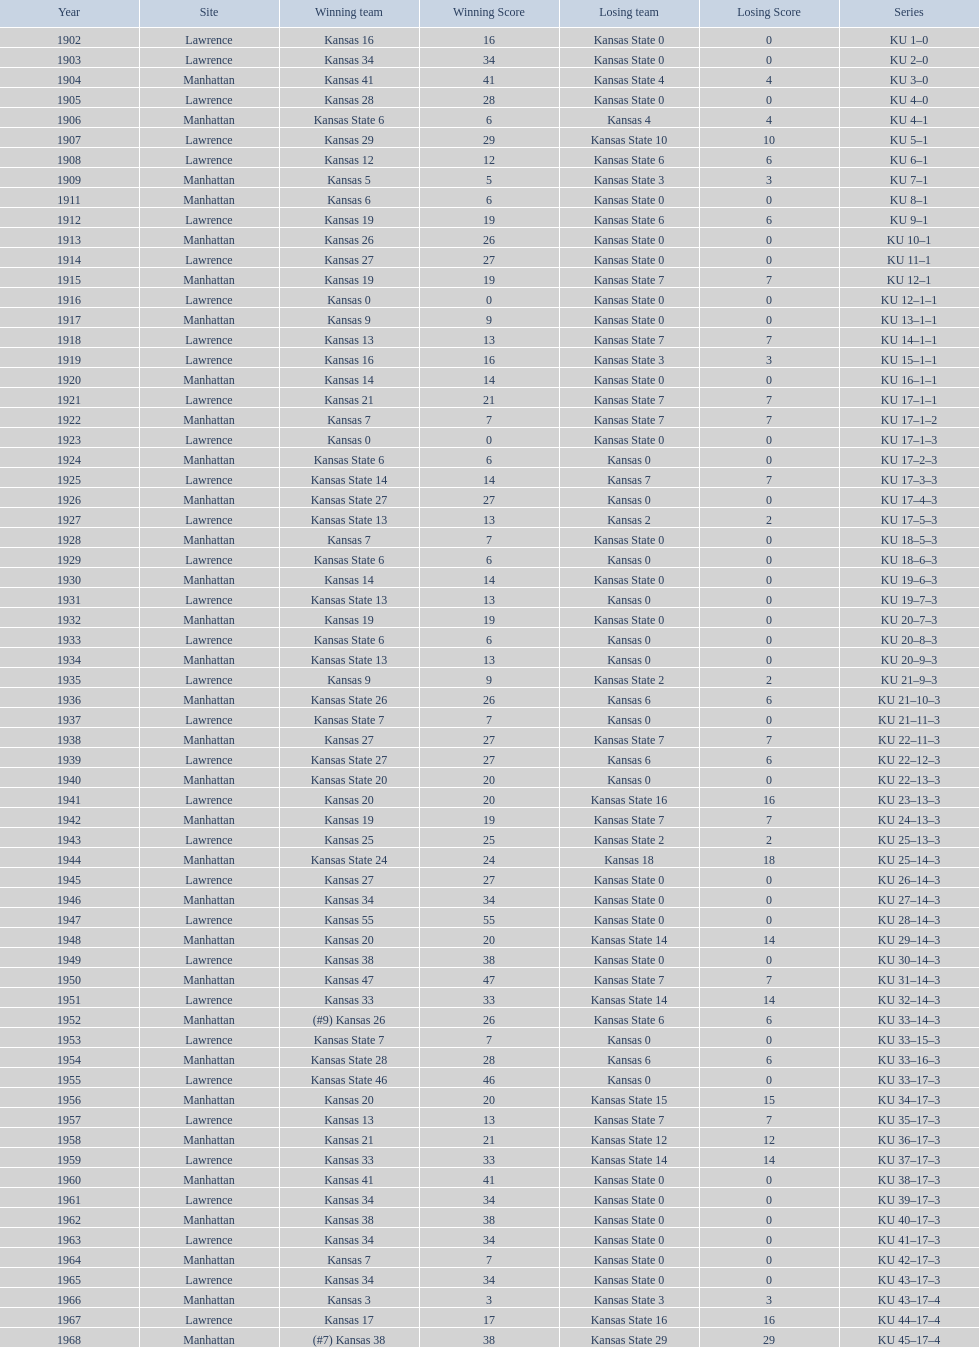I'm looking to parse the entire table for insights. Could you assist me with that? {'header': ['Year', 'Site', 'Winning team', 'Winning Score', 'Losing team', 'Losing Score', 'Series'], 'rows': [['1902', 'Lawrence', 'Kansas 16', '16', 'Kansas State 0', '0', 'KU 1–0'], ['1903', 'Lawrence', 'Kansas 34', '34', 'Kansas State 0', '0', 'KU 2–0'], ['1904', 'Manhattan', 'Kansas 41', '41', 'Kansas State 4', '4', 'KU 3–0'], ['1905', 'Lawrence', 'Kansas 28', '28', 'Kansas State 0', '0', 'KU 4–0'], ['1906', 'Manhattan', 'Kansas State 6', '6', 'Kansas 4', '4', 'KU 4–1'], ['1907', 'Lawrence', 'Kansas 29', '29', 'Kansas State 10', '10', 'KU 5–1'], ['1908', 'Lawrence', 'Kansas 12', '12', 'Kansas State 6', '6', 'KU 6–1'], ['1909', 'Manhattan', 'Kansas 5', '5', 'Kansas State 3', '3', 'KU 7–1'], ['1911', 'Manhattan', 'Kansas 6', '6', 'Kansas State 0', '0', 'KU 8–1'], ['1912', 'Lawrence', 'Kansas 19', '19', 'Kansas State 6', '6', 'KU 9–1'], ['1913', 'Manhattan', 'Kansas 26', '26', 'Kansas State 0', '0', 'KU 10–1'], ['1914', 'Lawrence', 'Kansas 27', '27', 'Kansas State 0', '0', 'KU 11–1'], ['1915', 'Manhattan', 'Kansas 19', '19', 'Kansas State 7', '7', 'KU 12–1'], ['1916', 'Lawrence', 'Kansas 0', '0', 'Kansas State 0', '0', 'KU 12–1–1'], ['1917', 'Manhattan', 'Kansas 9', '9', 'Kansas State 0', '0', 'KU 13–1–1'], ['1918', 'Lawrence', 'Kansas 13', '13', 'Kansas State 7', '7', 'KU 14–1–1'], ['1919', 'Lawrence', 'Kansas 16', '16', 'Kansas State 3', '3', 'KU 15–1–1'], ['1920', 'Manhattan', 'Kansas 14', '14', 'Kansas State 0', '0', 'KU 16–1–1'], ['1921', 'Lawrence', 'Kansas 21', '21', 'Kansas State 7', '7', 'KU 17–1–1'], ['1922', 'Manhattan', 'Kansas 7', '7', 'Kansas State 7', '7', 'KU 17–1–2'], ['1923', 'Lawrence', 'Kansas 0', '0', 'Kansas State 0', '0', 'KU 17–1–3'], ['1924', 'Manhattan', 'Kansas State 6', '6', 'Kansas 0', '0', 'KU 17–2–3'], ['1925', 'Lawrence', 'Kansas State 14', '14', 'Kansas 7', '7', 'KU 17–3–3'], ['1926', 'Manhattan', 'Kansas State 27', '27', 'Kansas 0', '0', 'KU 17–4–3'], ['1927', 'Lawrence', 'Kansas State 13', '13', 'Kansas 2', '2', 'KU 17–5–3'], ['1928', 'Manhattan', 'Kansas 7', '7', 'Kansas State 0', '0', 'KU 18–5–3'], ['1929', 'Lawrence', 'Kansas State 6', '6', 'Kansas 0', '0', 'KU 18–6–3'], ['1930', 'Manhattan', 'Kansas 14', '14', 'Kansas State 0', '0', 'KU 19–6–3'], ['1931', 'Lawrence', 'Kansas State 13', '13', 'Kansas 0', '0', 'KU 19–7–3'], ['1932', 'Manhattan', 'Kansas 19', '19', 'Kansas State 0', '0', 'KU 20–7–3'], ['1933', 'Lawrence', 'Kansas State 6', '6', 'Kansas 0', '0', 'KU 20–8–3'], ['1934', 'Manhattan', 'Kansas State 13', '13', 'Kansas 0', '0', 'KU 20–9–3'], ['1935', 'Lawrence', 'Kansas 9', '9', 'Kansas State 2', '2', 'KU 21–9–3'], ['1936', 'Manhattan', 'Kansas State 26', '26', 'Kansas 6', '6', 'KU 21–10–3'], ['1937', 'Lawrence', 'Kansas State 7', '7', 'Kansas 0', '0', 'KU 21–11–3'], ['1938', 'Manhattan', 'Kansas 27', '27', 'Kansas State 7', '7', 'KU 22–11–3'], ['1939', 'Lawrence', 'Kansas State 27', '27', 'Kansas 6', '6', 'KU 22–12–3'], ['1940', 'Manhattan', 'Kansas State 20', '20', 'Kansas 0', '0', 'KU 22–13–3'], ['1941', 'Lawrence', 'Kansas 20', '20', 'Kansas State 16', '16', 'KU 23–13–3'], ['1942', 'Manhattan', 'Kansas 19', '19', 'Kansas State 7', '7', 'KU 24–13–3'], ['1943', 'Lawrence', 'Kansas 25', '25', 'Kansas State 2', '2', 'KU 25–13–3'], ['1944', 'Manhattan', 'Kansas State 24', '24', 'Kansas 18', '18', 'KU 25–14–3'], ['1945', 'Lawrence', 'Kansas 27', '27', 'Kansas State 0', '0', 'KU 26–14–3'], ['1946', 'Manhattan', 'Kansas 34', '34', 'Kansas State 0', '0', 'KU 27–14–3'], ['1947', 'Lawrence', 'Kansas 55', '55', 'Kansas State 0', '0', 'KU 28–14–3'], ['1948', 'Manhattan', 'Kansas 20', '20', 'Kansas State 14', '14', 'KU 29–14–3'], ['1949', 'Lawrence', 'Kansas 38', '38', 'Kansas State 0', '0', 'KU 30–14–3'], ['1950', 'Manhattan', 'Kansas 47', '47', 'Kansas State 7', '7', 'KU 31–14–3'], ['1951', 'Lawrence', 'Kansas 33', '33', 'Kansas State 14', '14', 'KU 32–14–3'], ['1952', 'Manhattan', '(#9) Kansas 26', '26', 'Kansas State 6', '6', 'KU 33–14–3'], ['1953', 'Lawrence', 'Kansas State 7', '7', 'Kansas 0', '0', 'KU 33–15–3'], ['1954', 'Manhattan', 'Kansas State 28', '28', 'Kansas 6', '6', 'KU 33–16–3'], ['1955', 'Lawrence', 'Kansas State 46', '46', 'Kansas 0', '0', 'KU 33–17–3'], ['1956', 'Manhattan', 'Kansas 20', '20', 'Kansas State 15', '15', 'KU 34–17–3'], ['1957', 'Lawrence', 'Kansas 13', '13', 'Kansas State 7', '7', 'KU 35–17–3'], ['1958', 'Manhattan', 'Kansas 21', '21', 'Kansas State 12', '12', 'KU 36–17–3'], ['1959', 'Lawrence', 'Kansas 33', '33', 'Kansas State 14', '14', 'KU 37–17–3'], ['1960', 'Manhattan', 'Kansas 41', '41', 'Kansas State 0', '0', 'KU 38–17–3'], ['1961', 'Lawrence', 'Kansas 34', '34', 'Kansas State 0', '0', 'KU 39–17–3'], ['1962', 'Manhattan', 'Kansas 38', '38', 'Kansas State 0', '0', 'KU 40–17–3'], ['1963', 'Lawrence', 'Kansas 34', '34', 'Kansas State 0', '0', 'KU 41–17–3'], ['1964', 'Manhattan', 'Kansas 7', '7', 'Kansas State 0', '0', 'KU 42–17–3'], ['1965', 'Lawrence', 'Kansas 34', '34', 'Kansas State 0', '0', 'KU 43–17–3'], ['1966', 'Manhattan', 'Kansas 3', '3', 'Kansas State 3', '3', 'KU 43–17–4'], ['1967', 'Lawrence', 'Kansas 17', '17', 'Kansas State 16', '16', 'KU 44–17–4'], ['1968', 'Manhattan', '(#7) Kansas 38', '38', 'Kansas State 29', '29', 'KU 45–17–4']]} When was the first game that kansas state won by double digits? 1926. 